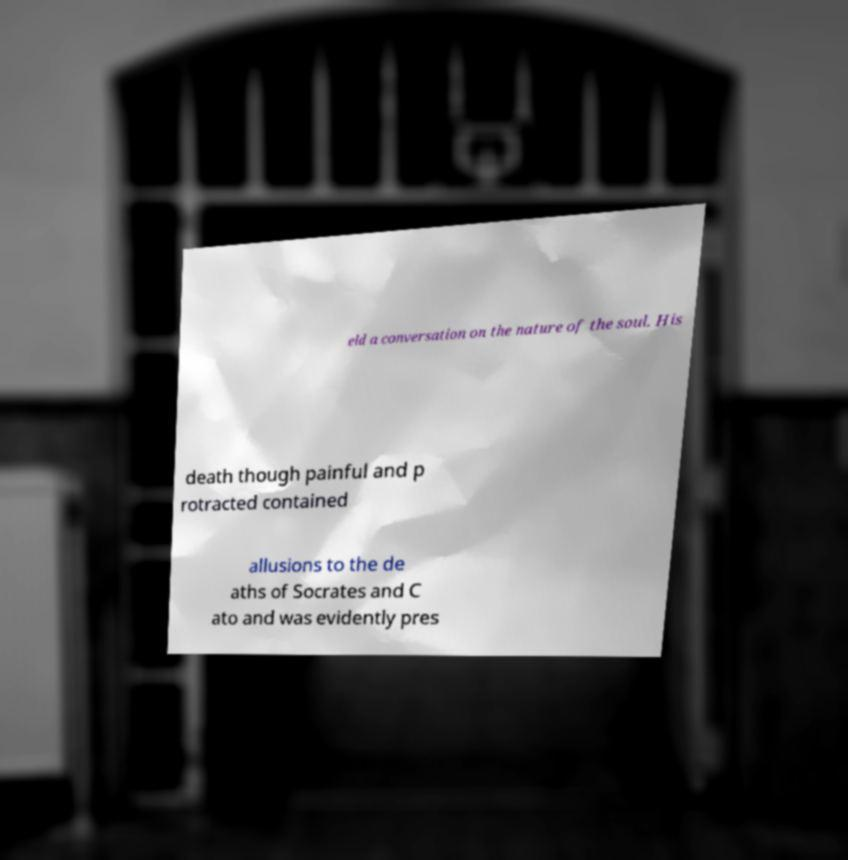Can you read and provide the text displayed in the image?This photo seems to have some interesting text. Can you extract and type it out for me? eld a conversation on the nature of the soul. His death though painful and p rotracted contained allusions to the de aths of Socrates and C ato and was evidently pres 